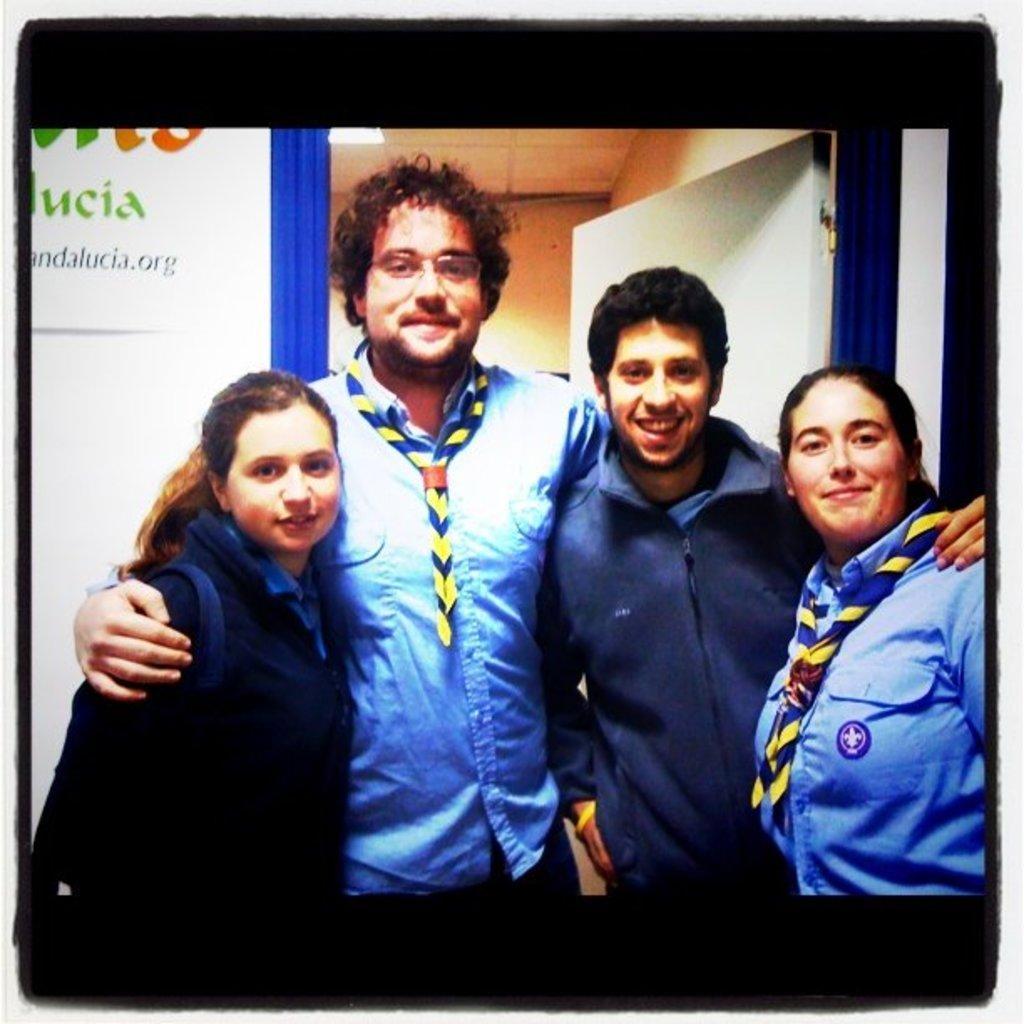Could you give a brief overview of what you see in this image? In the picture we can see a photograph of four people standing together and smiling and behind them we can see a wall with a board and written something on it and beside it we can see the entrance of another room with a door. 